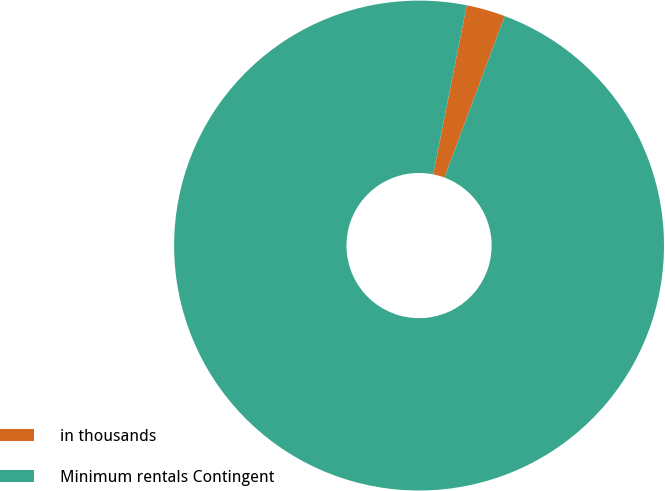Convert chart. <chart><loc_0><loc_0><loc_500><loc_500><pie_chart><fcel>in thousands<fcel>Minimum rentals Contingent<nl><fcel>2.57%<fcel>97.43%<nl></chart> 